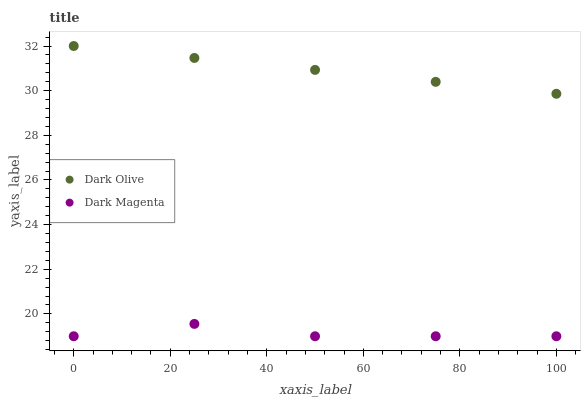Does Dark Magenta have the minimum area under the curve?
Answer yes or no. Yes. Does Dark Olive have the maximum area under the curve?
Answer yes or no. Yes. Does Dark Magenta have the maximum area under the curve?
Answer yes or no. No. Is Dark Olive the smoothest?
Answer yes or no. Yes. Is Dark Magenta the roughest?
Answer yes or no. Yes. Is Dark Magenta the smoothest?
Answer yes or no. No. Does Dark Magenta have the lowest value?
Answer yes or no. Yes. Does Dark Olive have the highest value?
Answer yes or no. Yes. Does Dark Magenta have the highest value?
Answer yes or no. No. Is Dark Magenta less than Dark Olive?
Answer yes or no. Yes. Is Dark Olive greater than Dark Magenta?
Answer yes or no. Yes. Does Dark Magenta intersect Dark Olive?
Answer yes or no. No. 